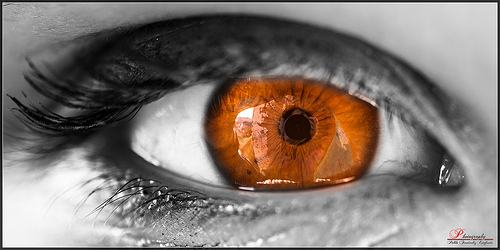<image>
Is there a eyelash to the left of the iris? Yes. From this viewpoint, the eyelash is positioned to the left side relative to the iris. 